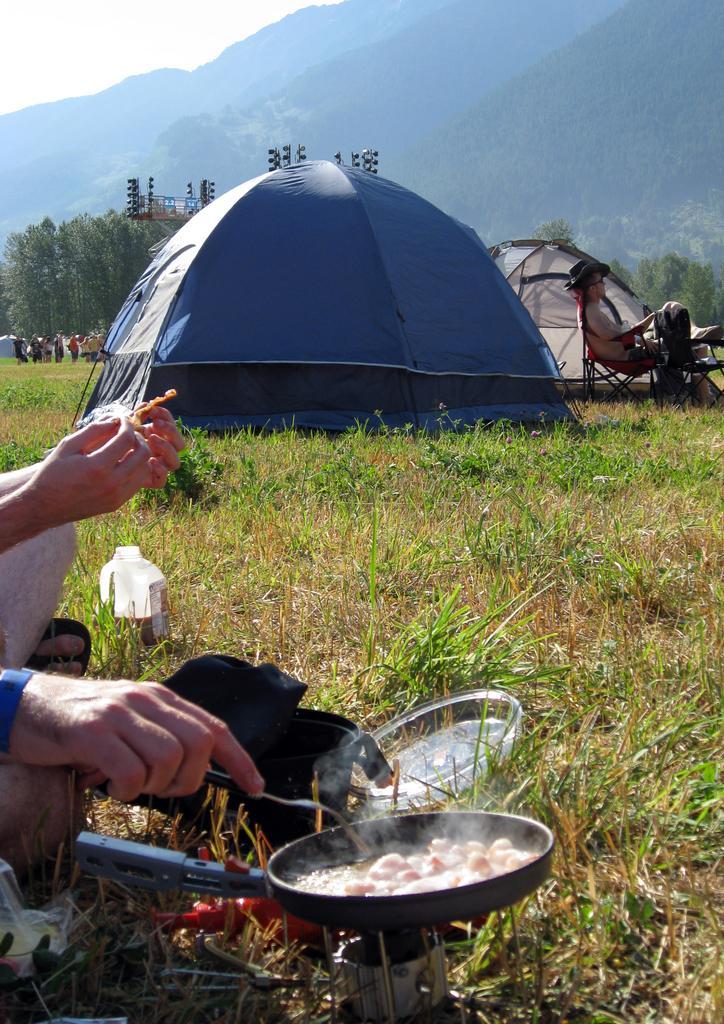Describe this image in one or two sentences. In front of the image there is a person´s hand holding a fork is cooking some food item in a pan on a stove, beside the person there is another person's hand, beside them there is a milk can, in the background of the image there are tents, a few people standing and a person sitting in a chair, behind them there are trees, some objects and mountains. 